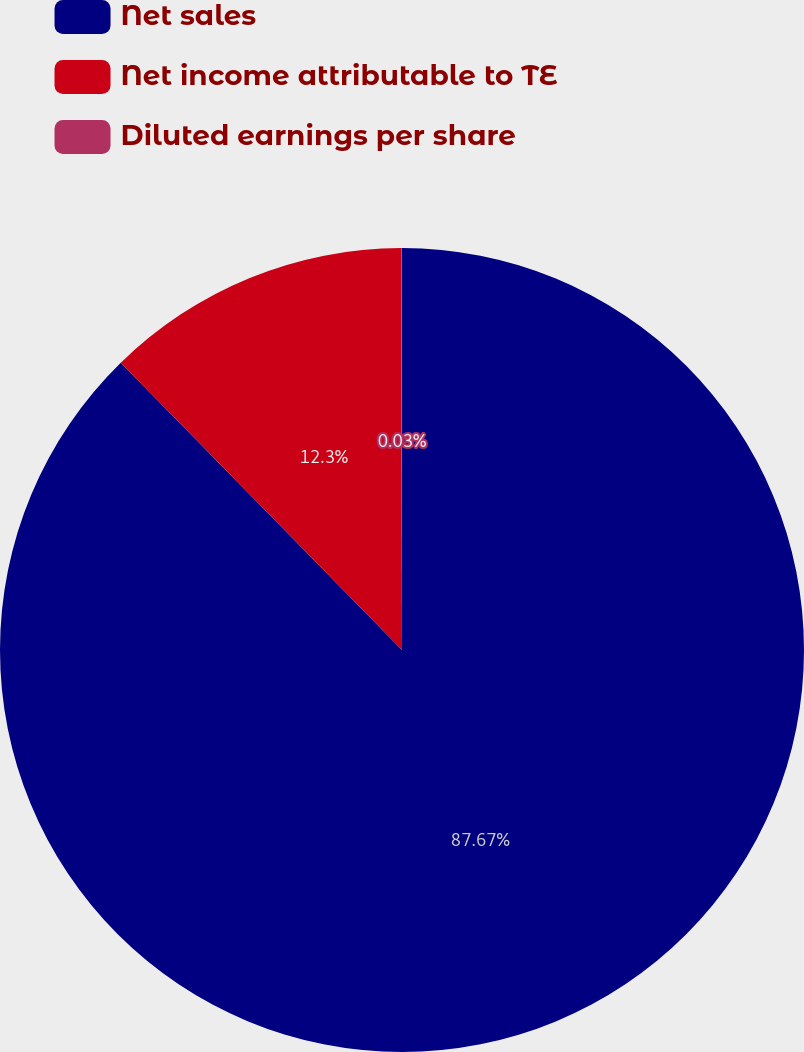<chart> <loc_0><loc_0><loc_500><loc_500><pie_chart><fcel>Net sales<fcel>Net income attributable to TE<fcel>Diluted earnings per share<nl><fcel>87.67%<fcel>12.3%<fcel>0.03%<nl></chart> 